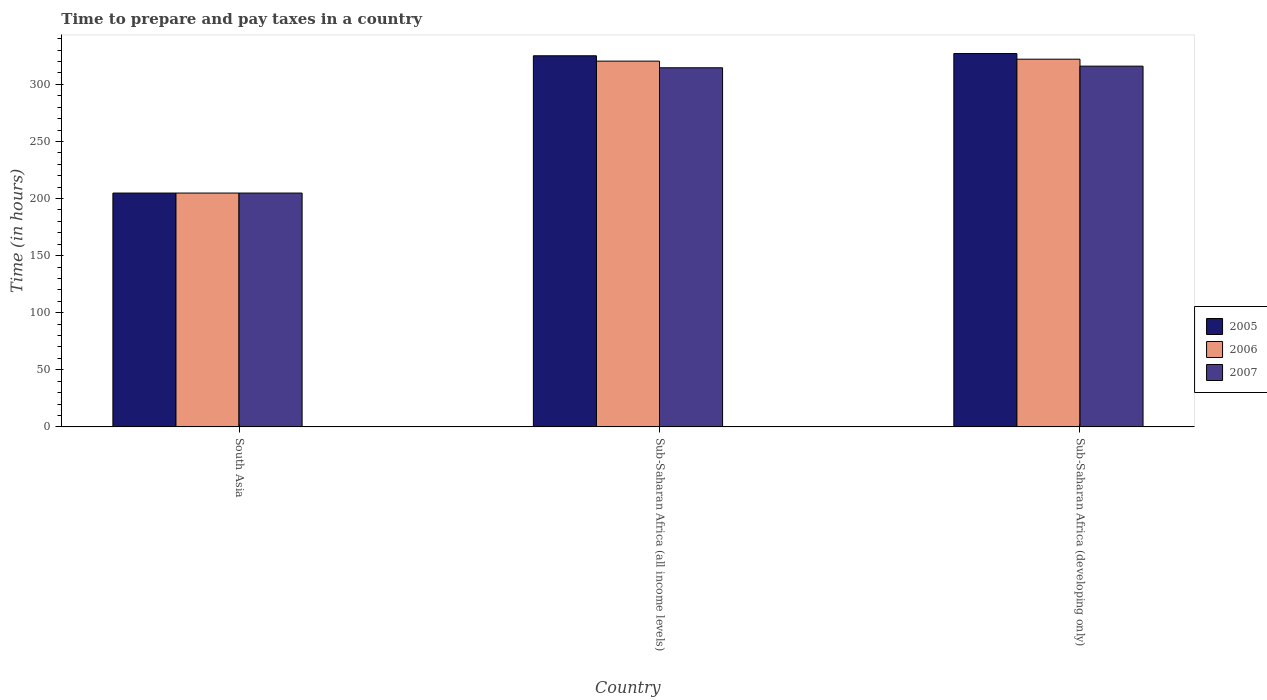How many groups of bars are there?
Provide a short and direct response. 3. Are the number of bars on each tick of the X-axis equal?
Offer a very short reply. Yes. How many bars are there on the 2nd tick from the right?
Your answer should be compact. 3. What is the label of the 2nd group of bars from the left?
Your response must be concise. Sub-Saharan Africa (all income levels). In how many cases, is the number of bars for a given country not equal to the number of legend labels?
Your answer should be very brief. 0. What is the number of hours required to prepare and pay taxes in 2007 in South Asia?
Offer a very short reply. 204.8. Across all countries, what is the maximum number of hours required to prepare and pay taxes in 2006?
Ensure brevity in your answer.  322.05. Across all countries, what is the minimum number of hours required to prepare and pay taxes in 2007?
Your answer should be very brief. 204.8. In which country was the number of hours required to prepare and pay taxes in 2005 maximum?
Offer a terse response. Sub-Saharan Africa (developing only). What is the total number of hours required to prepare and pay taxes in 2006 in the graph?
Give a very brief answer. 847.2. What is the difference between the number of hours required to prepare and pay taxes in 2006 in Sub-Saharan Africa (all income levels) and that in Sub-Saharan Africa (developing only)?
Give a very brief answer. -1.69. What is the difference between the number of hours required to prepare and pay taxes in 2006 in Sub-Saharan Africa (developing only) and the number of hours required to prepare and pay taxes in 2005 in Sub-Saharan Africa (all income levels)?
Your response must be concise. -3. What is the average number of hours required to prepare and pay taxes in 2005 per country?
Provide a succinct answer. 285.62. What is the difference between the number of hours required to prepare and pay taxes of/in 2005 and number of hours required to prepare and pay taxes of/in 2006 in Sub-Saharan Africa (all income levels)?
Your answer should be very brief. 4.69. What is the ratio of the number of hours required to prepare and pay taxes in 2005 in South Asia to that in Sub-Saharan Africa (all income levels)?
Provide a short and direct response. 0.63. Is the difference between the number of hours required to prepare and pay taxes in 2005 in South Asia and Sub-Saharan Africa (developing only) greater than the difference between the number of hours required to prepare and pay taxes in 2006 in South Asia and Sub-Saharan Africa (developing only)?
Your response must be concise. No. What is the difference between the highest and the second highest number of hours required to prepare and pay taxes in 2007?
Your answer should be compact. -1.42. What is the difference between the highest and the lowest number of hours required to prepare and pay taxes in 2006?
Provide a succinct answer. 117.25. In how many countries, is the number of hours required to prepare and pay taxes in 2005 greater than the average number of hours required to prepare and pay taxes in 2005 taken over all countries?
Give a very brief answer. 2. Is the sum of the number of hours required to prepare and pay taxes in 2006 in Sub-Saharan Africa (all income levels) and Sub-Saharan Africa (developing only) greater than the maximum number of hours required to prepare and pay taxes in 2005 across all countries?
Give a very brief answer. Yes. Is it the case that in every country, the sum of the number of hours required to prepare and pay taxes in 2005 and number of hours required to prepare and pay taxes in 2007 is greater than the number of hours required to prepare and pay taxes in 2006?
Give a very brief answer. Yes. How many countries are there in the graph?
Provide a succinct answer. 3. What is the difference between two consecutive major ticks on the Y-axis?
Provide a succinct answer. 50. Does the graph contain any zero values?
Your response must be concise. No. How are the legend labels stacked?
Provide a short and direct response. Vertical. What is the title of the graph?
Your answer should be very brief. Time to prepare and pay taxes in a country. Does "2004" appear as one of the legend labels in the graph?
Make the answer very short. No. What is the label or title of the Y-axis?
Provide a succinct answer. Time (in hours). What is the Time (in hours) in 2005 in South Asia?
Provide a short and direct response. 204.8. What is the Time (in hours) of 2006 in South Asia?
Ensure brevity in your answer.  204.8. What is the Time (in hours) of 2007 in South Asia?
Offer a terse response. 204.8. What is the Time (in hours) in 2005 in Sub-Saharan Africa (all income levels)?
Your answer should be compact. 325.05. What is the Time (in hours) in 2006 in Sub-Saharan Africa (all income levels)?
Keep it short and to the point. 320.36. What is the Time (in hours) of 2007 in Sub-Saharan Africa (all income levels)?
Your answer should be very brief. 314.53. What is the Time (in hours) of 2005 in Sub-Saharan Africa (developing only)?
Ensure brevity in your answer.  327. What is the Time (in hours) in 2006 in Sub-Saharan Africa (developing only)?
Offer a terse response. 322.05. What is the Time (in hours) of 2007 in Sub-Saharan Africa (developing only)?
Give a very brief answer. 315.95. Across all countries, what is the maximum Time (in hours) in 2005?
Provide a short and direct response. 327. Across all countries, what is the maximum Time (in hours) in 2006?
Your response must be concise. 322.05. Across all countries, what is the maximum Time (in hours) in 2007?
Offer a very short reply. 315.95. Across all countries, what is the minimum Time (in hours) of 2005?
Your answer should be very brief. 204.8. Across all countries, what is the minimum Time (in hours) of 2006?
Your answer should be compact. 204.8. Across all countries, what is the minimum Time (in hours) of 2007?
Your response must be concise. 204.8. What is the total Time (in hours) in 2005 in the graph?
Give a very brief answer. 856.85. What is the total Time (in hours) in 2006 in the graph?
Your answer should be very brief. 847.2. What is the total Time (in hours) of 2007 in the graph?
Offer a terse response. 835.29. What is the difference between the Time (in hours) in 2005 in South Asia and that in Sub-Saharan Africa (all income levels)?
Keep it short and to the point. -120.25. What is the difference between the Time (in hours) of 2006 in South Asia and that in Sub-Saharan Africa (all income levels)?
Give a very brief answer. -115.56. What is the difference between the Time (in hours) of 2007 in South Asia and that in Sub-Saharan Africa (all income levels)?
Offer a very short reply. -109.73. What is the difference between the Time (in hours) of 2005 in South Asia and that in Sub-Saharan Africa (developing only)?
Keep it short and to the point. -122.2. What is the difference between the Time (in hours) of 2006 in South Asia and that in Sub-Saharan Africa (developing only)?
Offer a very short reply. -117.25. What is the difference between the Time (in hours) of 2007 in South Asia and that in Sub-Saharan Africa (developing only)?
Your answer should be compact. -111.15. What is the difference between the Time (in hours) in 2005 in Sub-Saharan Africa (all income levels) and that in Sub-Saharan Africa (developing only)?
Make the answer very short. -1.95. What is the difference between the Time (in hours) of 2006 in Sub-Saharan Africa (all income levels) and that in Sub-Saharan Africa (developing only)?
Offer a terse response. -1.69. What is the difference between the Time (in hours) in 2007 in Sub-Saharan Africa (all income levels) and that in Sub-Saharan Africa (developing only)?
Your response must be concise. -1.42. What is the difference between the Time (in hours) in 2005 in South Asia and the Time (in hours) in 2006 in Sub-Saharan Africa (all income levels)?
Provide a succinct answer. -115.56. What is the difference between the Time (in hours) of 2005 in South Asia and the Time (in hours) of 2007 in Sub-Saharan Africa (all income levels)?
Ensure brevity in your answer.  -109.73. What is the difference between the Time (in hours) in 2006 in South Asia and the Time (in hours) in 2007 in Sub-Saharan Africa (all income levels)?
Keep it short and to the point. -109.73. What is the difference between the Time (in hours) of 2005 in South Asia and the Time (in hours) of 2006 in Sub-Saharan Africa (developing only)?
Make the answer very short. -117.25. What is the difference between the Time (in hours) of 2005 in South Asia and the Time (in hours) of 2007 in Sub-Saharan Africa (developing only)?
Provide a succinct answer. -111.15. What is the difference between the Time (in hours) in 2006 in South Asia and the Time (in hours) in 2007 in Sub-Saharan Africa (developing only)?
Your response must be concise. -111.15. What is the difference between the Time (in hours) in 2005 in Sub-Saharan Africa (all income levels) and the Time (in hours) in 2006 in Sub-Saharan Africa (developing only)?
Your answer should be compact. 3. What is the difference between the Time (in hours) of 2005 in Sub-Saharan Africa (all income levels) and the Time (in hours) of 2007 in Sub-Saharan Africa (developing only)?
Your response must be concise. 9.09. What is the difference between the Time (in hours) in 2006 in Sub-Saharan Africa (all income levels) and the Time (in hours) in 2007 in Sub-Saharan Africa (developing only)?
Make the answer very short. 4.4. What is the average Time (in hours) of 2005 per country?
Your answer should be very brief. 285.62. What is the average Time (in hours) in 2006 per country?
Give a very brief answer. 282.4. What is the average Time (in hours) of 2007 per country?
Provide a short and direct response. 278.43. What is the difference between the Time (in hours) of 2005 and Time (in hours) of 2007 in South Asia?
Offer a terse response. 0. What is the difference between the Time (in hours) in 2006 and Time (in hours) in 2007 in South Asia?
Your response must be concise. 0. What is the difference between the Time (in hours) of 2005 and Time (in hours) of 2006 in Sub-Saharan Africa (all income levels)?
Your answer should be compact. 4.69. What is the difference between the Time (in hours) in 2005 and Time (in hours) in 2007 in Sub-Saharan Africa (all income levels)?
Offer a terse response. 10.51. What is the difference between the Time (in hours) in 2006 and Time (in hours) in 2007 in Sub-Saharan Africa (all income levels)?
Offer a very short reply. 5.82. What is the difference between the Time (in hours) in 2005 and Time (in hours) in 2006 in Sub-Saharan Africa (developing only)?
Keep it short and to the point. 4.95. What is the difference between the Time (in hours) of 2005 and Time (in hours) of 2007 in Sub-Saharan Africa (developing only)?
Your answer should be very brief. 11.05. What is the difference between the Time (in hours) in 2006 and Time (in hours) in 2007 in Sub-Saharan Africa (developing only)?
Provide a short and direct response. 6.09. What is the ratio of the Time (in hours) of 2005 in South Asia to that in Sub-Saharan Africa (all income levels)?
Provide a short and direct response. 0.63. What is the ratio of the Time (in hours) in 2006 in South Asia to that in Sub-Saharan Africa (all income levels)?
Provide a succinct answer. 0.64. What is the ratio of the Time (in hours) of 2007 in South Asia to that in Sub-Saharan Africa (all income levels)?
Your answer should be very brief. 0.65. What is the ratio of the Time (in hours) of 2005 in South Asia to that in Sub-Saharan Africa (developing only)?
Your response must be concise. 0.63. What is the ratio of the Time (in hours) of 2006 in South Asia to that in Sub-Saharan Africa (developing only)?
Offer a very short reply. 0.64. What is the ratio of the Time (in hours) of 2007 in South Asia to that in Sub-Saharan Africa (developing only)?
Ensure brevity in your answer.  0.65. What is the ratio of the Time (in hours) of 2007 in Sub-Saharan Africa (all income levels) to that in Sub-Saharan Africa (developing only)?
Provide a short and direct response. 1. What is the difference between the highest and the second highest Time (in hours) in 2005?
Provide a succinct answer. 1.95. What is the difference between the highest and the second highest Time (in hours) of 2006?
Your answer should be compact. 1.69. What is the difference between the highest and the second highest Time (in hours) of 2007?
Offer a terse response. 1.42. What is the difference between the highest and the lowest Time (in hours) in 2005?
Provide a succinct answer. 122.2. What is the difference between the highest and the lowest Time (in hours) of 2006?
Provide a short and direct response. 117.25. What is the difference between the highest and the lowest Time (in hours) of 2007?
Your answer should be very brief. 111.15. 